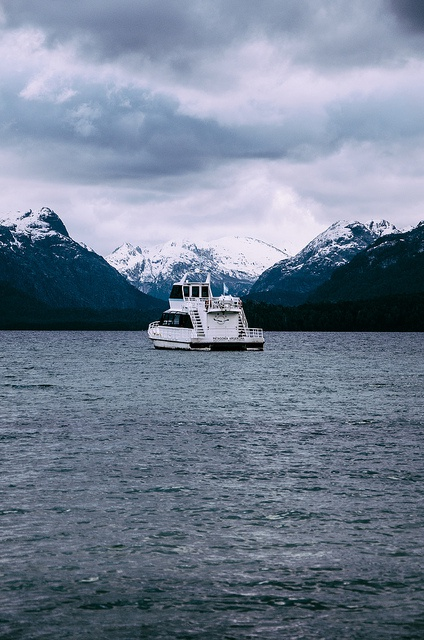Describe the objects in this image and their specific colors. I can see a boat in darkgray, black, and lavender tones in this image. 